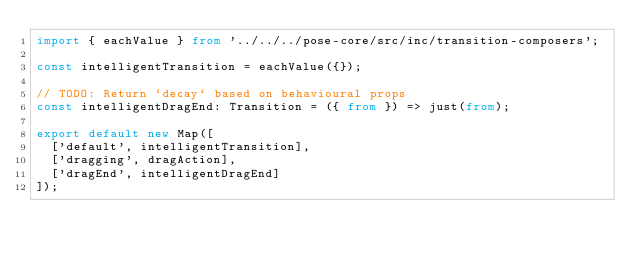Convert code to text. <code><loc_0><loc_0><loc_500><loc_500><_TypeScript_>import { eachValue } from '../../../pose-core/src/inc/transition-composers';

const intelligentTransition = eachValue({});

// TODO: Return `decay` based on behavioural props
const intelligentDragEnd: Transition = ({ from }) => just(from);

export default new Map([
  ['default', intelligentTransition],
  ['dragging', dragAction],
  ['dragEnd', intelligentDragEnd]
]);
</code> 